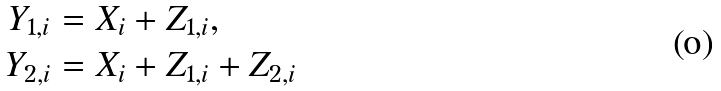<formula> <loc_0><loc_0><loc_500><loc_500>Y _ { 1 , i } & = X _ { i } + Z _ { 1 , i } , \\ Y _ { 2 , i } & = X _ { i } + Z _ { 1 , i } + Z _ { 2 , i }</formula> 